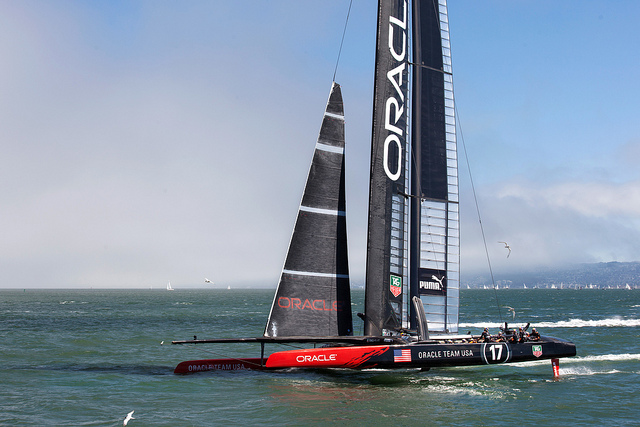Read and extract the text from this image. ORACLE ORACLE PUMA ORACLE TEAM USA 17 ORACL 